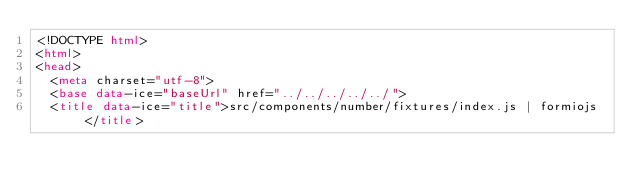Convert code to text. <code><loc_0><loc_0><loc_500><loc_500><_HTML_><!DOCTYPE html>
<html>
<head>
  <meta charset="utf-8">
  <base data-ice="baseUrl" href="../../../../../">
  <title data-ice="title">src/components/number/fixtures/index.js | formiojs</title></code> 